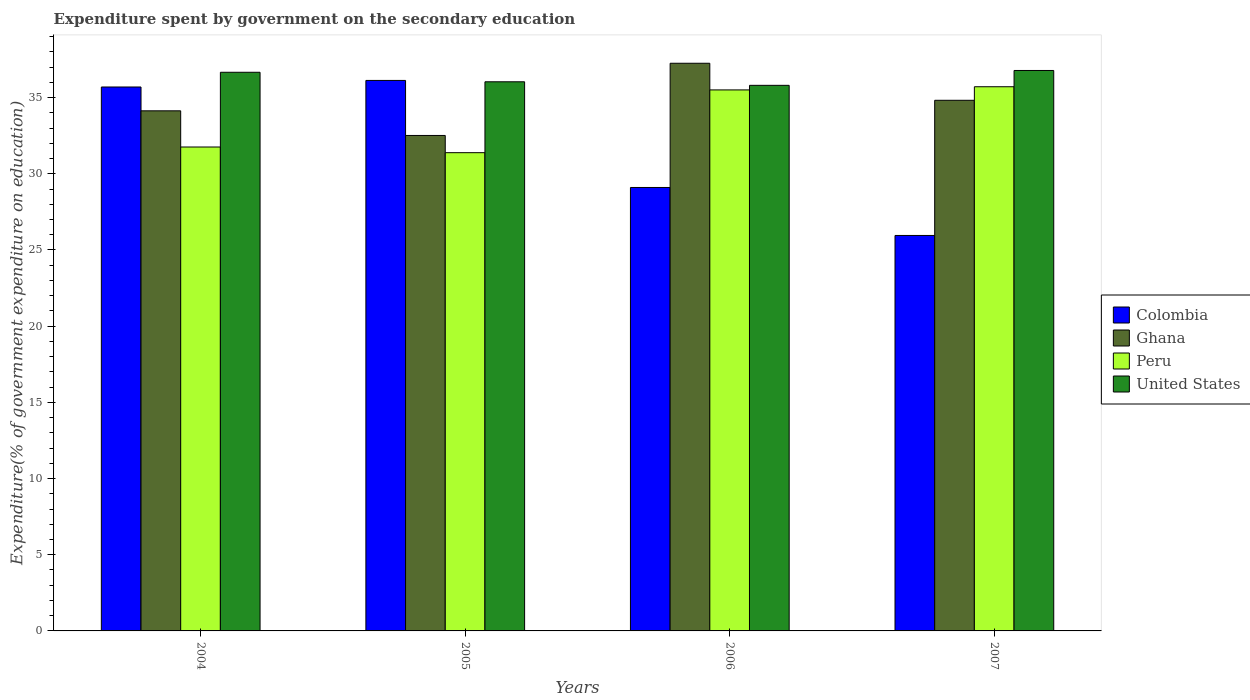How many different coloured bars are there?
Offer a very short reply. 4. How many groups of bars are there?
Provide a succinct answer. 4. Are the number of bars on each tick of the X-axis equal?
Give a very brief answer. Yes. How many bars are there on the 2nd tick from the left?
Offer a very short reply. 4. What is the expenditure spent by government on the secondary education in United States in 2005?
Provide a short and direct response. 36.04. Across all years, what is the maximum expenditure spent by government on the secondary education in Peru?
Give a very brief answer. 35.71. Across all years, what is the minimum expenditure spent by government on the secondary education in United States?
Your response must be concise. 35.81. In which year was the expenditure spent by government on the secondary education in Ghana maximum?
Offer a very short reply. 2006. In which year was the expenditure spent by government on the secondary education in Ghana minimum?
Keep it short and to the point. 2005. What is the total expenditure spent by government on the secondary education in Ghana in the graph?
Your answer should be compact. 138.73. What is the difference between the expenditure spent by government on the secondary education in Ghana in 2004 and that in 2005?
Offer a terse response. 1.62. What is the difference between the expenditure spent by government on the secondary education in Peru in 2005 and the expenditure spent by government on the secondary education in United States in 2006?
Offer a very short reply. -4.42. What is the average expenditure spent by government on the secondary education in Peru per year?
Provide a short and direct response. 33.59. In the year 2004, what is the difference between the expenditure spent by government on the secondary education in Colombia and expenditure spent by government on the secondary education in Ghana?
Keep it short and to the point. 1.56. What is the ratio of the expenditure spent by government on the secondary education in Colombia in 2006 to that in 2007?
Make the answer very short. 1.12. Is the expenditure spent by government on the secondary education in Peru in 2004 less than that in 2006?
Your answer should be compact. Yes. What is the difference between the highest and the second highest expenditure spent by government on the secondary education in Peru?
Give a very brief answer. 0.21. What is the difference between the highest and the lowest expenditure spent by government on the secondary education in Peru?
Give a very brief answer. 4.33. Is the sum of the expenditure spent by government on the secondary education in United States in 2005 and 2006 greater than the maximum expenditure spent by government on the secondary education in Peru across all years?
Your answer should be compact. Yes. Is it the case that in every year, the sum of the expenditure spent by government on the secondary education in United States and expenditure spent by government on the secondary education in Ghana is greater than the sum of expenditure spent by government on the secondary education in Colombia and expenditure spent by government on the secondary education in Peru?
Your response must be concise. No. Are all the bars in the graph horizontal?
Your answer should be very brief. No. Are the values on the major ticks of Y-axis written in scientific E-notation?
Offer a very short reply. No. Where does the legend appear in the graph?
Offer a terse response. Center right. How many legend labels are there?
Provide a succinct answer. 4. How are the legend labels stacked?
Keep it short and to the point. Vertical. What is the title of the graph?
Your answer should be very brief. Expenditure spent by government on the secondary education. What is the label or title of the X-axis?
Make the answer very short. Years. What is the label or title of the Y-axis?
Your answer should be very brief. Expenditure(% of government expenditure on education). What is the Expenditure(% of government expenditure on education) in Colombia in 2004?
Provide a short and direct response. 35.7. What is the Expenditure(% of government expenditure on education) of Ghana in 2004?
Your answer should be compact. 34.13. What is the Expenditure(% of government expenditure on education) in Peru in 2004?
Ensure brevity in your answer.  31.76. What is the Expenditure(% of government expenditure on education) of United States in 2004?
Your answer should be compact. 36.66. What is the Expenditure(% of government expenditure on education) in Colombia in 2005?
Make the answer very short. 36.13. What is the Expenditure(% of government expenditure on education) in Ghana in 2005?
Keep it short and to the point. 32.52. What is the Expenditure(% of government expenditure on education) in Peru in 2005?
Your answer should be compact. 31.39. What is the Expenditure(% of government expenditure on education) of United States in 2005?
Your response must be concise. 36.04. What is the Expenditure(% of government expenditure on education) of Colombia in 2006?
Your answer should be compact. 29.1. What is the Expenditure(% of government expenditure on education) of Ghana in 2006?
Provide a short and direct response. 37.25. What is the Expenditure(% of government expenditure on education) of Peru in 2006?
Your response must be concise. 35.5. What is the Expenditure(% of government expenditure on education) of United States in 2006?
Provide a short and direct response. 35.81. What is the Expenditure(% of government expenditure on education) of Colombia in 2007?
Provide a short and direct response. 25.95. What is the Expenditure(% of government expenditure on education) of Ghana in 2007?
Your answer should be very brief. 34.82. What is the Expenditure(% of government expenditure on education) in Peru in 2007?
Offer a terse response. 35.71. What is the Expenditure(% of government expenditure on education) of United States in 2007?
Offer a very short reply. 36.78. Across all years, what is the maximum Expenditure(% of government expenditure on education) of Colombia?
Offer a very short reply. 36.13. Across all years, what is the maximum Expenditure(% of government expenditure on education) in Ghana?
Provide a short and direct response. 37.25. Across all years, what is the maximum Expenditure(% of government expenditure on education) of Peru?
Your answer should be compact. 35.71. Across all years, what is the maximum Expenditure(% of government expenditure on education) in United States?
Provide a succinct answer. 36.78. Across all years, what is the minimum Expenditure(% of government expenditure on education) of Colombia?
Keep it short and to the point. 25.95. Across all years, what is the minimum Expenditure(% of government expenditure on education) in Ghana?
Provide a short and direct response. 32.52. Across all years, what is the minimum Expenditure(% of government expenditure on education) of Peru?
Make the answer very short. 31.39. Across all years, what is the minimum Expenditure(% of government expenditure on education) of United States?
Provide a short and direct response. 35.81. What is the total Expenditure(% of government expenditure on education) of Colombia in the graph?
Your answer should be compact. 126.88. What is the total Expenditure(% of government expenditure on education) of Ghana in the graph?
Your answer should be compact. 138.73. What is the total Expenditure(% of government expenditure on education) of Peru in the graph?
Offer a very short reply. 134.36. What is the total Expenditure(% of government expenditure on education) in United States in the graph?
Make the answer very short. 145.29. What is the difference between the Expenditure(% of government expenditure on education) in Colombia in 2004 and that in 2005?
Provide a succinct answer. -0.43. What is the difference between the Expenditure(% of government expenditure on education) of Ghana in 2004 and that in 2005?
Provide a succinct answer. 1.62. What is the difference between the Expenditure(% of government expenditure on education) of Peru in 2004 and that in 2005?
Make the answer very short. 0.37. What is the difference between the Expenditure(% of government expenditure on education) of United States in 2004 and that in 2005?
Give a very brief answer. 0.62. What is the difference between the Expenditure(% of government expenditure on education) of Colombia in 2004 and that in 2006?
Ensure brevity in your answer.  6.59. What is the difference between the Expenditure(% of government expenditure on education) of Ghana in 2004 and that in 2006?
Offer a very short reply. -3.12. What is the difference between the Expenditure(% of government expenditure on education) in Peru in 2004 and that in 2006?
Provide a succinct answer. -3.75. What is the difference between the Expenditure(% of government expenditure on education) of United States in 2004 and that in 2006?
Offer a terse response. 0.86. What is the difference between the Expenditure(% of government expenditure on education) of Colombia in 2004 and that in 2007?
Offer a terse response. 9.74. What is the difference between the Expenditure(% of government expenditure on education) in Ghana in 2004 and that in 2007?
Provide a short and direct response. -0.69. What is the difference between the Expenditure(% of government expenditure on education) in Peru in 2004 and that in 2007?
Offer a very short reply. -3.95. What is the difference between the Expenditure(% of government expenditure on education) of United States in 2004 and that in 2007?
Your answer should be compact. -0.12. What is the difference between the Expenditure(% of government expenditure on education) of Colombia in 2005 and that in 2006?
Offer a terse response. 7.03. What is the difference between the Expenditure(% of government expenditure on education) in Ghana in 2005 and that in 2006?
Keep it short and to the point. -4.74. What is the difference between the Expenditure(% of government expenditure on education) in Peru in 2005 and that in 2006?
Your answer should be compact. -4.12. What is the difference between the Expenditure(% of government expenditure on education) in United States in 2005 and that in 2006?
Offer a terse response. 0.23. What is the difference between the Expenditure(% of government expenditure on education) of Colombia in 2005 and that in 2007?
Keep it short and to the point. 10.18. What is the difference between the Expenditure(% of government expenditure on education) in Ghana in 2005 and that in 2007?
Your answer should be compact. -2.31. What is the difference between the Expenditure(% of government expenditure on education) in Peru in 2005 and that in 2007?
Your answer should be compact. -4.33. What is the difference between the Expenditure(% of government expenditure on education) of United States in 2005 and that in 2007?
Make the answer very short. -0.74. What is the difference between the Expenditure(% of government expenditure on education) of Colombia in 2006 and that in 2007?
Keep it short and to the point. 3.15. What is the difference between the Expenditure(% of government expenditure on education) of Ghana in 2006 and that in 2007?
Your response must be concise. 2.43. What is the difference between the Expenditure(% of government expenditure on education) in Peru in 2006 and that in 2007?
Ensure brevity in your answer.  -0.21. What is the difference between the Expenditure(% of government expenditure on education) in United States in 2006 and that in 2007?
Give a very brief answer. -0.97. What is the difference between the Expenditure(% of government expenditure on education) in Colombia in 2004 and the Expenditure(% of government expenditure on education) in Ghana in 2005?
Ensure brevity in your answer.  3.18. What is the difference between the Expenditure(% of government expenditure on education) in Colombia in 2004 and the Expenditure(% of government expenditure on education) in Peru in 2005?
Offer a very short reply. 4.31. What is the difference between the Expenditure(% of government expenditure on education) of Colombia in 2004 and the Expenditure(% of government expenditure on education) of United States in 2005?
Provide a succinct answer. -0.34. What is the difference between the Expenditure(% of government expenditure on education) of Ghana in 2004 and the Expenditure(% of government expenditure on education) of Peru in 2005?
Offer a terse response. 2.75. What is the difference between the Expenditure(% of government expenditure on education) of Ghana in 2004 and the Expenditure(% of government expenditure on education) of United States in 2005?
Offer a terse response. -1.91. What is the difference between the Expenditure(% of government expenditure on education) in Peru in 2004 and the Expenditure(% of government expenditure on education) in United States in 2005?
Provide a succinct answer. -4.28. What is the difference between the Expenditure(% of government expenditure on education) of Colombia in 2004 and the Expenditure(% of government expenditure on education) of Ghana in 2006?
Make the answer very short. -1.56. What is the difference between the Expenditure(% of government expenditure on education) of Colombia in 2004 and the Expenditure(% of government expenditure on education) of Peru in 2006?
Ensure brevity in your answer.  0.19. What is the difference between the Expenditure(% of government expenditure on education) of Colombia in 2004 and the Expenditure(% of government expenditure on education) of United States in 2006?
Your answer should be compact. -0.11. What is the difference between the Expenditure(% of government expenditure on education) in Ghana in 2004 and the Expenditure(% of government expenditure on education) in Peru in 2006?
Your answer should be compact. -1.37. What is the difference between the Expenditure(% of government expenditure on education) of Ghana in 2004 and the Expenditure(% of government expenditure on education) of United States in 2006?
Provide a succinct answer. -1.67. What is the difference between the Expenditure(% of government expenditure on education) of Peru in 2004 and the Expenditure(% of government expenditure on education) of United States in 2006?
Provide a succinct answer. -4.05. What is the difference between the Expenditure(% of government expenditure on education) in Colombia in 2004 and the Expenditure(% of government expenditure on education) in Ghana in 2007?
Make the answer very short. 0.87. What is the difference between the Expenditure(% of government expenditure on education) of Colombia in 2004 and the Expenditure(% of government expenditure on education) of Peru in 2007?
Your answer should be compact. -0.02. What is the difference between the Expenditure(% of government expenditure on education) of Colombia in 2004 and the Expenditure(% of government expenditure on education) of United States in 2007?
Provide a short and direct response. -1.08. What is the difference between the Expenditure(% of government expenditure on education) in Ghana in 2004 and the Expenditure(% of government expenditure on education) in Peru in 2007?
Provide a short and direct response. -1.58. What is the difference between the Expenditure(% of government expenditure on education) in Ghana in 2004 and the Expenditure(% of government expenditure on education) in United States in 2007?
Give a very brief answer. -2.65. What is the difference between the Expenditure(% of government expenditure on education) in Peru in 2004 and the Expenditure(% of government expenditure on education) in United States in 2007?
Your answer should be compact. -5.02. What is the difference between the Expenditure(% of government expenditure on education) of Colombia in 2005 and the Expenditure(% of government expenditure on education) of Ghana in 2006?
Your answer should be very brief. -1.13. What is the difference between the Expenditure(% of government expenditure on education) of Colombia in 2005 and the Expenditure(% of government expenditure on education) of Peru in 2006?
Offer a very short reply. 0.62. What is the difference between the Expenditure(% of government expenditure on education) in Colombia in 2005 and the Expenditure(% of government expenditure on education) in United States in 2006?
Your answer should be very brief. 0.32. What is the difference between the Expenditure(% of government expenditure on education) in Ghana in 2005 and the Expenditure(% of government expenditure on education) in Peru in 2006?
Ensure brevity in your answer.  -2.99. What is the difference between the Expenditure(% of government expenditure on education) of Ghana in 2005 and the Expenditure(% of government expenditure on education) of United States in 2006?
Ensure brevity in your answer.  -3.29. What is the difference between the Expenditure(% of government expenditure on education) in Peru in 2005 and the Expenditure(% of government expenditure on education) in United States in 2006?
Keep it short and to the point. -4.42. What is the difference between the Expenditure(% of government expenditure on education) of Colombia in 2005 and the Expenditure(% of government expenditure on education) of Ghana in 2007?
Your answer should be compact. 1.3. What is the difference between the Expenditure(% of government expenditure on education) in Colombia in 2005 and the Expenditure(% of government expenditure on education) in Peru in 2007?
Make the answer very short. 0.42. What is the difference between the Expenditure(% of government expenditure on education) of Colombia in 2005 and the Expenditure(% of government expenditure on education) of United States in 2007?
Your answer should be compact. -0.65. What is the difference between the Expenditure(% of government expenditure on education) in Ghana in 2005 and the Expenditure(% of government expenditure on education) in Peru in 2007?
Your response must be concise. -3.2. What is the difference between the Expenditure(% of government expenditure on education) of Ghana in 2005 and the Expenditure(% of government expenditure on education) of United States in 2007?
Offer a terse response. -4.26. What is the difference between the Expenditure(% of government expenditure on education) in Peru in 2005 and the Expenditure(% of government expenditure on education) in United States in 2007?
Give a very brief answer. -5.39. What is the difference between the Expenditure(% of government expenditure on education) of Colombia in 2006 and the Expenditure(% of government expenditure on education) of Ghana in 2007?
Give a very brief answer. -5.72. What is the difference between the Expenditure(% of government expenditure on education) of Colombia in 2006 and the Expenditure(% of government expenditure on education) of Peru in 2007?
Ensure brevity in your answer.  -6.61. What is the difference between the Expenditure(% of government expenditure on education) of Colombia in 2006 and the Expenditure(% of government expenditure on education) of United States in 2007?
Your response must be concise. -7.68. What is the difference between the Expenditure(% of government expenditure on education) in Ghana in 2006 and the Expenditure(% of government expenditure on education) in Peru in 2007?
Your response must be concise. 1.54. What is the difference between the Expenditure(% of government expenditure on education) in Ghana in 2006 and the Expenditure(% of government expenditure on education) in United States in 2007?
Give a very brief answer. 0.47. What is the difference between the Expenditure(% of government expenditure on education) of Peru in 2006 and the Expenditure(% of government expenditure on education) of United States in 2007?
Provide a short and direct response. -1.28. What is the average Expenditure(% of government expenditure on education) of Colombia per year?
Keep it short and to the point. 31.72. What is the average Expenditure(% of government expenditure on education) of Ghana per year?
Ensure brevity in your answer.  34.68. What is the average Expenditure(% of government expenditure on education) in Peru per year?
Keep it short and to the point. 33.59. What is the average Expenditure(% of government expenditure on education) in United States per year?
Your response must be concise. 36.32. In the year 2004, what is the difference between the Expenditure(% of government expenditure on education) of Colombia and Expenditure(% of government expenditure on education) of Ghana?
Your answer should be very brief. 1.56. In the year 2004, what is the difference between the Expenditure(% of government expenditure on education) in Colombia and Expenditure(% of government expenditure on education) in Peru?
Provide a short and direct response. 3.94. In the year 2004, what is the difference between the Expenditure(% of government expenditure on education) in Colombia and Expenditure(% of government expenditure on education) in United States?
Your response must be concise. -0.97. In the year 2004, what is the difference between the Expenditure(% of government expenditure on education) of Ghana and Expenditure(% of government expenditure on education) of Peru?
Your answer should be very brief. 2.37. In the year 2004, what is the difference between the Expenditure(% of government expenditure on education) of Ghana and Expenditure(% of government expenditure on education) of United States?
Provide a short and direct response. -2.53. In the year 2004, what is the difference between the Expenditure(% of government expenditure on education) in Peru and Expenditure(% of government expenditure on education) in United States?
Your answer should be compact. -4.9. In the year 2005, what is the difference between the Expenditure(% of government expenditure on education) of Colombia and Expenditure(% of government expenditure on education) of Ghana?
Give a very brief answer. 3.61. In the year 2005, what is the difference between the Expenditure(% of government expenditure on education) of Colombia and Expenditure(% of government expenditure on education) of Peru?
Your answer should be very brief. 4.74. In the year 2005, what is the difference between the Expenditure(% of government expenditure on education) of Colombia and Expenditure(% of government expenditure on education) of United States?
Offer a terse response. 0.09. In the year 2005, what is the difference between the Expenditure(% of government expenditure on education) in Ghana and Expenditure(% of government expenditure on education) in Peru?
Keep it short and to the point. 1.13. In the year 2005, what is the difference between the Expenditure(% of government expenditure on education) in Ghana and Expenditure(% of government expenditure on education) in United States?
Give a very brief answer. -3.52. In the year 2005, what is the difference between the Expenditure(% of government expenditure on education) of Peru and Expenditure(% of government expenditure on education) of United States?
Provide a short and direct response. -4.65. In the year 2006, what is the difference between the Expenditure(% of government expenditure on education) in Colombia and Expenditure(% of government expenditure on education) in Ghana?
Provide a succinct answer. -8.15. In the year 2006, what is the difference between the Expenditure(% of government expenditure on education) in Colombia and Expenditure(% of government expenditure on education) in Peru?
Offer a terse response. -6.4. In the year 2006, what is the difference between the Expenditure(% of government expenditure on education) of Colombia and Expenditure(% of government expenditure on education) of United States?
Your response must be concise. -6.7. In the year 2006, what is the difference between the Expenditure(% of government expenditure on education) in Ghana and Expenditure(% of government expenditure on education) in Peru?
Make the answer very short. 1.75. In the year 2006, what is the difference between the Expenditure(% of government expenditure on education) of Ghana and Expenditure(% of government expenditure on education) of United States?
Your answer should be compact. 1.45. In the year 2006, what is the difference between the Expenditure(% of government expenditure on education) of Peru and Expenditure(% of government expenditure on education) of United States?
Give a very brief answer. -0.3. In the year 2007, what is the difference between the Expenditure(% of government expenditure on education) of Colombia and Expenditure(% of government expenditure on education) of Ghana?
Provide a succinct answer. -8.87. In the year 2007, what is the difference between the Expenditure(% of government expenditure on education) of Colombia and Expenditure(% of government expenditure on education) of Peru?
Offer a terse response. -9.76. In the year 2007, what is the difference between the Expenditure(% of government expenditure on education) in Colombia and Expenditure(% of government expenditure on education) in United States?
Make the answer very short. -10.83. In the year 2007, what is the difference between the Expenditure(% of government expenditure on education) in Ghana and Expenditure(% of government expenditure on education) in Peru?
Your answer should be compact. -0.89. In the year 2007, what is the difference between the Expenditure(% of government expenditure on education) of Ghana and Expenditure(% of government expenditure on education) of United States?
Your response must be concise. -1.96. In the year 2007, what is the difference between the Expenditure(% of government expenditure on education) of Peru and Expenditure(% of government expenditure on education) of United States?
Offer a very short reply. -1.07. What is the ratio of the Expenditure(% of government expenditure on education) in Ghana in 2004 to that in 2005?
Keep it short and to the point. 1.05. What is the ratio of the Expenditure(% of government expenditure on education) of Peru in 2004 to that in 2005?
Provide a short and direct response. 1.01. What is the ratio of the Expenditure(% of government expenditure on education) in United States in 2004 to that in 2005?
Keep it short and to the point. 1.02. What is the ratio of the Expenditure(% of government expenditure on education) in Colombia in 2004 to that in 2006?
Keep it short and to the point. 1.23. What is the ratio of the Expenditure(% of government expenditure on education) of Ghana in 2004 to that in 2006?
Provide a succinct answer. 0.92. What is the ratio of the Expenditure(% of government expenditure on education) in Peru in 2004 to that in 2006?
Ensure brevity in your answer.  0.89. What is the ratio of the Expenditure(% of government expenditure on education) in United States in 2004 to that in 2006?
Your answer should be compact. 1.02. What is the ratio of the Expenditure(% of government expenditure on education) of Colombia in 2004 to that in 2007?
Offer a very short reply. 1.38. What is the ratio of the Expenditure(% of government expenditure on education) in Ghana in 2004 to that in 2007?
Provide a short and direct response. 0.98. What is the ratio of the Expenditure(% of government expenditure on education) of Peru in 2004 to that in 2007?
Offer a terse response. 0.89. What is the ratio of the Expenditure(% of government expenditure on education) of Colombia in 2005 to that in 2006?
Offer a very short reply. 1.24. What is the ratio of the Expenditure(% of government expenditure on education) of Ghana in 2005 to that in 2006?
Provide a succinct answer. 0.87. What is the ratio of the Expenditure(% of government expenditure on education) in Peru in 2005 to that in 2006?
Offer a terse response. 0.88. What is the ratio of the Expenditure(% of government expenditure on education) in Colombia in 2005 to that in 2007?
Make the answer very short. 1.39. What is the ratio of the Expenditure(% of government expenditure on education) of Ghana in 2005 to that in 2007?
Offer a very short reply. 0.93. What is the ratio of the Expenditure(% of government expenditure on education) of Peru in 2005 to that in 2007?
Your response must be concise. 0.88. What is the ratio of the Expenditure(% of government expenditure on education) of United States in 2005 to that in 2007?
Give a very brief answer. 0.98. What is the ratio of the Expenditure(% of government expenditure on education) in Colombia in 2006 to that in 2007?
Give a very brief answer. 1.12. What is the ratio of the Expenditure(% of government expenditure on education) in Ghana in 2006 to that in 2007?
Your response must be concise. 1.07. What is the ratio of the Expenditure(% of government expenditure on education) of United States in 2006 to that in 2007?
Provide a succinct answer. 0.97. What is the difference between the highest and the second highest Expenditure(% of government expenditure on education) of Colombia?
Your response must be concise. 0.43. What is the difference between the highest and the second highest Expenditure(% of government expenditure on education) in Ghana?
Provide a succinct answer. 2.43. What is the difference between the highest and the second highest Expenditure(% of government expenditure on education) of Peru?
Your answer should be very brief. 0.21. What is the difference between the highest and the second highest Expenditure(% of government expenditure on education) of United States?
Your response must be concise. 0.12. What is the difference between the highest and the lowest Expenditure(% of government expenditure on education) of Colombia?
Your answer should be very brief. 10.18. What is the difference between the highest and the lowest Expenditure(% of government expenditure on education) of Ghana?
Provide a short and direct response. 4.74. What is the difference between the highest and the lowest Expenditure(% of government expenditure on education) of Peru?
Make the answer very short. 4.33. What is the difference between the highest and the lowest Expenditure(% of government expenditure on education) of United States?
Your response must be concise. 0.97. 